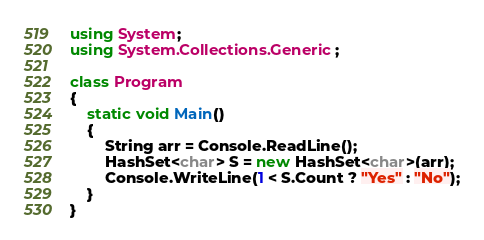Convert code to text. <code><loc_0><loc_0><loc_500><loc_500><_C#_>using System;
using System.Collections.Generic;

class Program
{
    static void Main()
    {
        String arr = Console.ReadLine();
        HashSet<char> S = new HashSet<char>(arr);
        Console.WriteLine(1 < S.Count ? "Yes" : "No");
    }
}</code> 